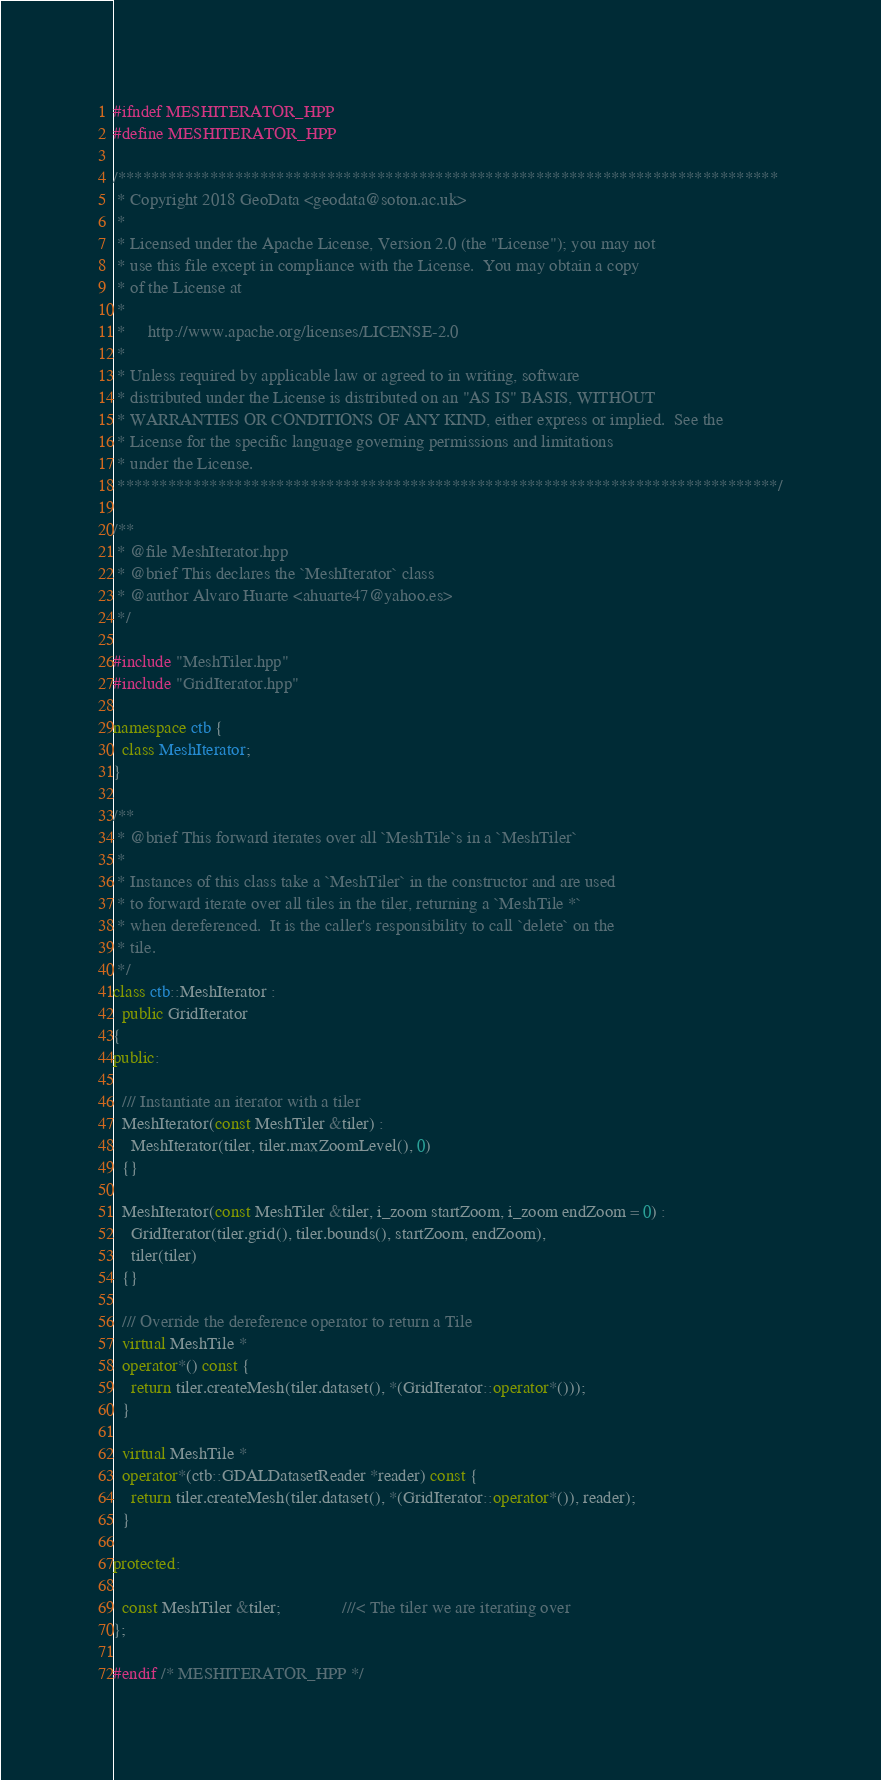Convert code to text. <code><loc_0><loc_0><loc_500><loc_500><_C++_>#ifndef MESHITERATOR_HPP
#define MESHITERATOR_HPP

/*******************************************************************************
 * Copyright 2018 GeoData <geodata@soton.ac.uk>
 *
 * Licensed under the Apache License, Version 2.0 (the "License"); you may not
 * use this file except in compliance with the License.  You may obtain a copy
 * of the License at
 *
 *     http://www.apache.org/licenses/LICENSE-2.0
 *
 * Unless required by applicable law or agreed to in writing, software
 * distributed under the License is distributed on an "AS IS" BASIS, WITHOUT
 * WARRANTIES OR CONDITIONS OF ANY KIND, either express or implied.  See the
 * License for the specific language governing permissions and limitations
 * under the License.
 *******************************************************************************/

/**
 * @file MeshIterator.hpp
 * @brief This declares the `MeshIterator` class
 * @author Alvaro Huarte <ahuarte47@yahoo.es>
 */

#include "MeshTiler.hpp"
#include "GridIterator.hpp"

namespace ctb {
  class MeshIterator;
}

/**
 * @brief This forward iterates over all `MeshTile`s in a `MeshTiler`
 *
 * Instances of this class take a `MeshTiler` in the constructor and are used
 * to forward iterate over all tiles in the tiler, returning a `MeshTile *`
 * when dereferenced.  It is the caller's responsibility to call `delete` on the
 * tile.
 */
class ctb::MeshIterator :
  public GridIterator
{
public:

  /// Instantiate an iterator with a tiler
  MeshIterator(const MeshTiler &tiler) :
    MeshIterator(tiler, tiler.maxZoomLevel(), 0)
  {}

  MeshIterator(const MeshTiler &tiler, i_zoom startZoom, i_zoom endZoom = 0) :
    GridIterator(tiler.grid(), tiler.bounds(), startZoom, endZoom),
    tiler(tiler)
  {}

  /// Override the dereference operator to return a Tile
  virtual MeshTile *
  operator*() const {
    return tiler.createMesh(tiler.dataset(), *(GridIterator::operator*()));
  }

  virtual MeshTile *
  operator*(ctb::GDALDatasetReader *reader) const {
    return tiler.createMesh(tiler.dataset(), *(GridIterator::operator*()), reader);
  }

protected:

  const MeshTiler &tiler;              ///< The tiler we are iterating over
};

#endif /* MESHITERATOR_HPP */
</code> 